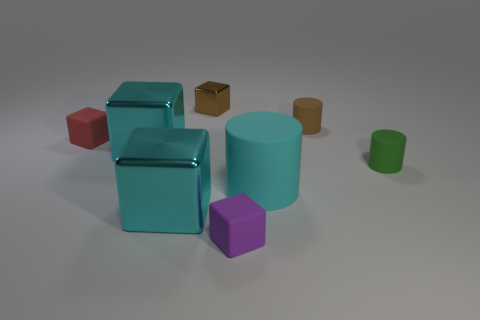What number of purple objects have the same size as the cyan matte thing?
Your answer should be compact. 0. How many things are small red matte objects or small brown matte objects behind the red object?
Provide a succinct answer. 2. What is the shape of the small purple matte object?
Your answer should be compact. Cube. There is another cylinder that is the same size as the green cylinder; what color is it?
Provide a short and direct response. Brown. How many purple things are tiny matte things or tiny metal blocks?
Offer a terse response. 1. Are there more tiny green matte things than tiny yellow metal cylinders?
Provide a short and direct response. Yes. Is the size of the red block that is behind the cyan cylinder the same as the cylinder behind the tiny green cylinder?
Provide a succinct answer. Yes. The big block that is behind the matte cylinder that is right of the tiny rubber cylinder that is behind the green rubber thing is what color?
Ensure brevity in your answer.  Cyan. Are there any cyan things that have the same shape as the purple matte object?
Ensure brevity in your answer.  Yes. Is the number of big cyan metallic cubes behind the tiny green cylinder greater than the number of tiny gray matte cubes?
Offer a terse response. Yes. 